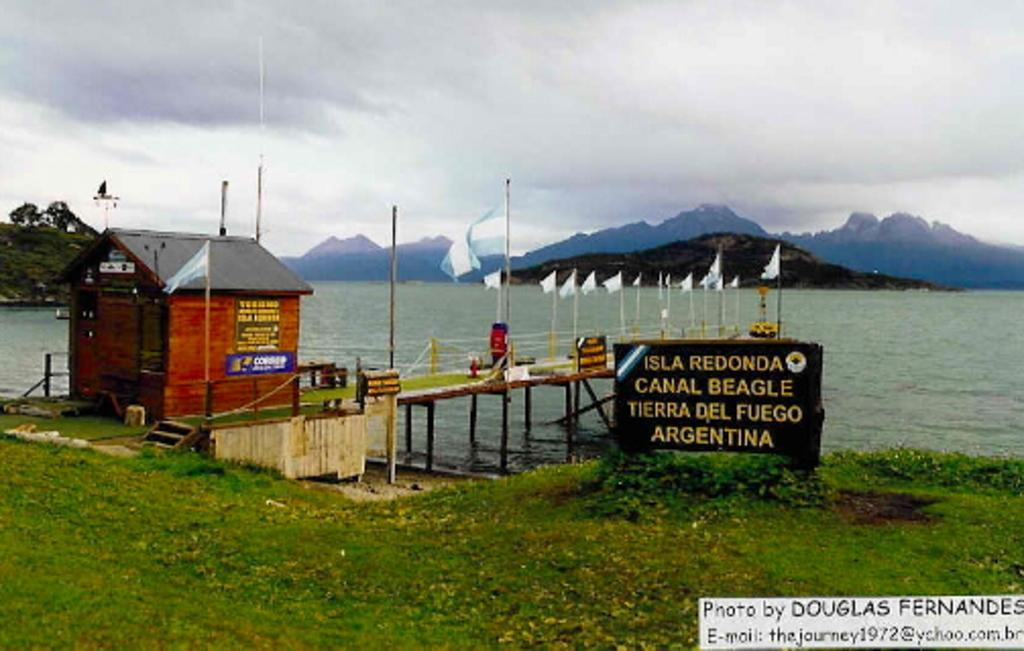Where was the image taken? The image was clicked outside. What is the main subject in the middle of the image? There is water and mountains in the middle of the image. What is visible on the left side of the image? There is some room on the left side of the image. What is visible at the top of the image? The sky is visible at the top of the image. What type of texture can be seen on the cars in the image? There are no cars present in the image, so there is no texture to describe. 